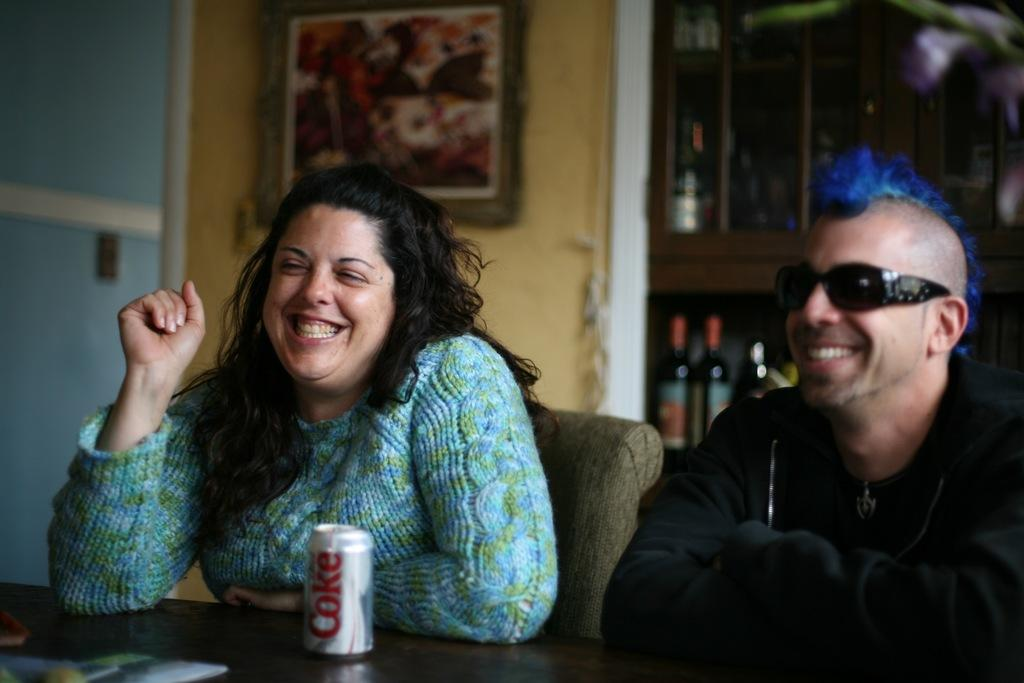How many people are in the image? There are two people in the image. What are the people doing in the image? The people are sitting on chairs. What is present in the image besides the people? There is a table in the image. What can be seen on the table? There is a Coke can on the table. What type of pipe can be seen in the image? There is no pipe present in the image. Can you hear a whistle in the image? There is no whistle present in the image, and therefore no sound can be heard. 